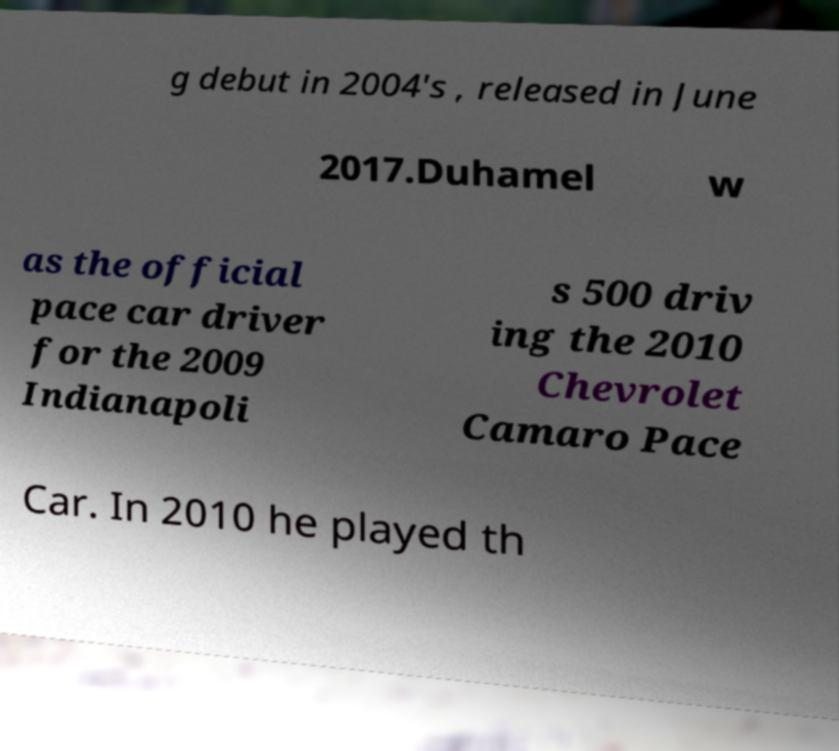Can you accurately transcribe the text from the provided image for me? g debut in 2004's , released in June 2017.Duhamel w as the official pace car driver for the 2009 Indianapoli s 500 driv ing the 2010 Chevrolet Camaro Pace Car. In 2010 he played th 